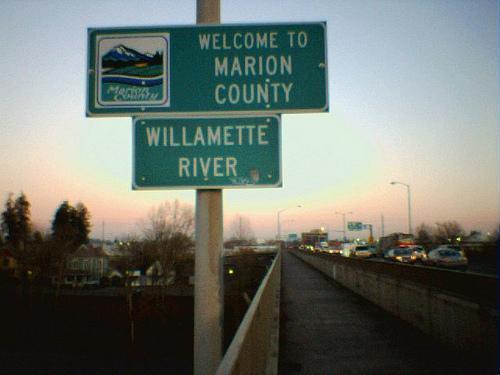How many signs are there?
Give a very brief answer. 2. 